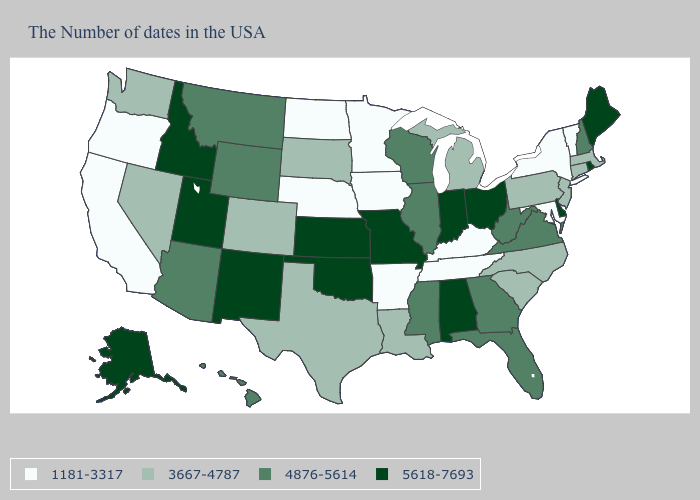Does the map have missing data?
Concise answer only. No. Does Kentucky have the lowest value in the South?
Quick response, please. Yes. Does Rhode Island have the highest value in the USA?
Concise answer only. Yes. Among the states that border Missouri , which have the lowest value?
Keep it brief. Kentucky, Tennessee, Arkansas, Iowa, Nebraska. Which states have the lowest value in the West?
Write a very short answer. California, Oregon. What is the value of New Mexico?
Be succinct. 5618-7693. What is the highest value in the USA?
Answer briefly. 5618-7693. Which states hav the highest value in the West?
Write a very short answer. New Mexico, Utah, Idaho, Alaska. What is the value of Iowa?
Keep it brief. 1181-3317. Among the states that border Texas , does New Mexico have the highest value?
Concise answer only. Yes. What is the highest value in the USA?
Give a very brief answer. 5618-7693. How many symbols are there in the legend?
Quick response, please. 4. What is the value of North Carolina?
Write a very short answer. 3667-4787. Name the states that have a value in the range 5618-7693?
Answer briefly. Maine, Rhode Island, Delaware, Ohio, Indiana, Alabama, Missouri, Kansas, Oklahoma, New Mexico, Utah, Idaho, Alaska. Name the states that have a value in the range 5618-7693?
Quick response, please. Maine, Rhode Island, Delaware, Ohio, Indiana, Alabama, Missouri, Kansas, Oklahoma, New Mexico, Utah, Idaho, Alaska. 